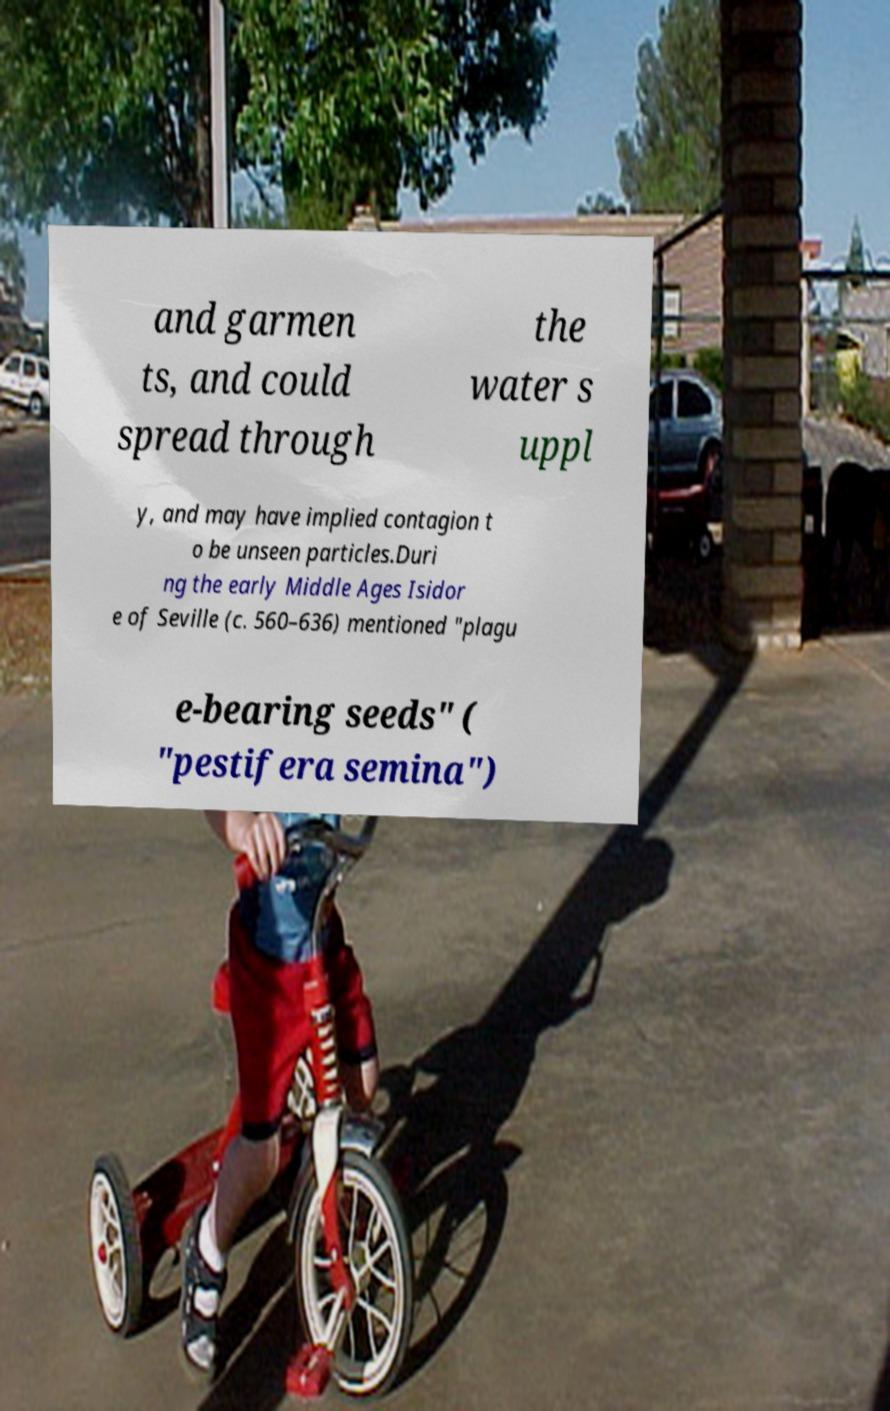Can you read and provide the text displayed in the image?This photo seems to have some interesting text. Can you extract and type it out for me? and garmen ts, and could spread through the water s uppl y, and may have implied contagion t o be unseen particles.Duri ng the early Middle Ages Isidor e of Seville (c. 560–636) mentioned "plagu e-bearing seeds" ( "pestifera semina") 